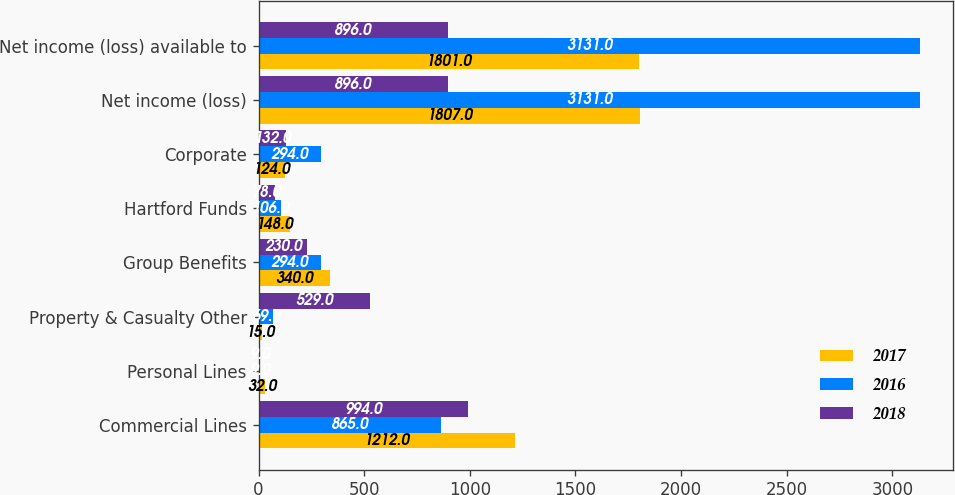Convert chart to OTSL. <chart><loc_0><loc_0><loc_500><loc_500><stacked_bar_chart><ecel><fcel>Commercial Lines<fcel>Personal Lines<fcel>Property & Casualty Other<fcel>Group Benefits<fcel>Hartford Funds<fcel>Corporate<fcel>Net income (loss)<fcel>Net income (loss) available to<nl><fcel>2017<fcel>1212<fcel>32<fcel>15<fcel>340<fcel>148<fcel>124<fcel>1807<fcel>1801<nl><fcel>2016<fcel>865<fcel>9<fcel>69<fcel>294<fcel>106<fcel>294<fcel>3131<fcel>3131<nl><fcel>2018<fcel>994<fcel>9<fcel>529<fcel>230<fcel>78<fcel>132<fcel>896<fcel>896<nl></chart> 